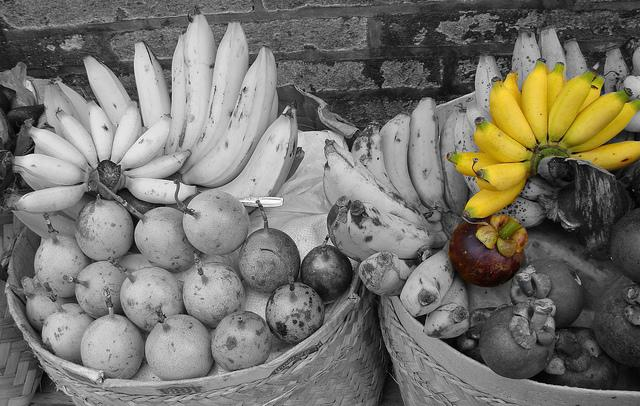Where is this produce located? basket 